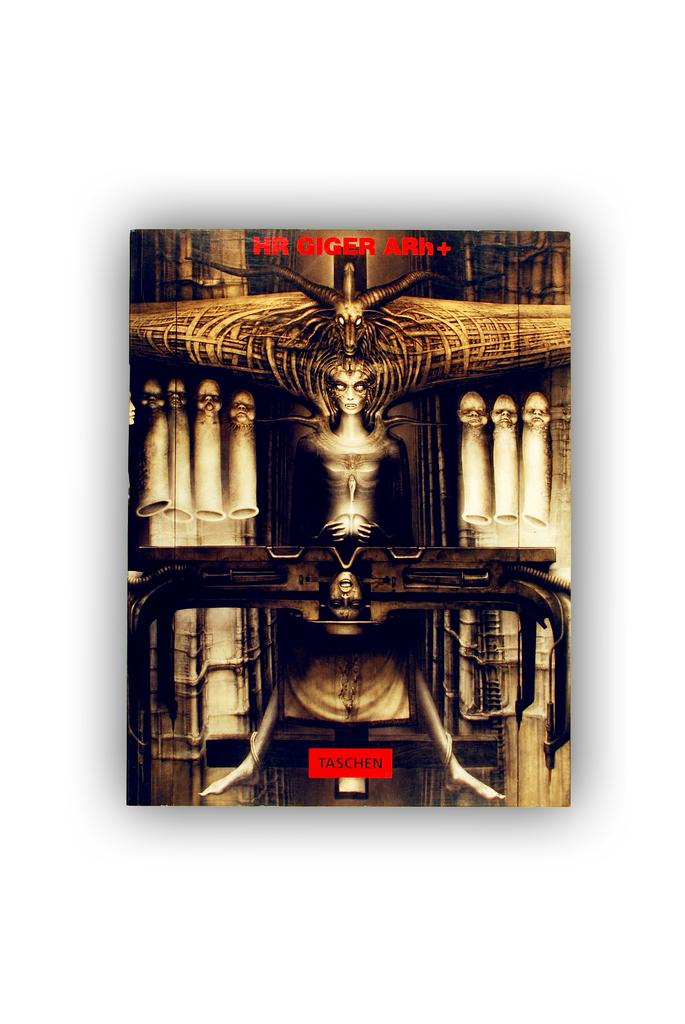What does the words in red at the top say?
Provide a short and direct response. Hr giger arh+. 